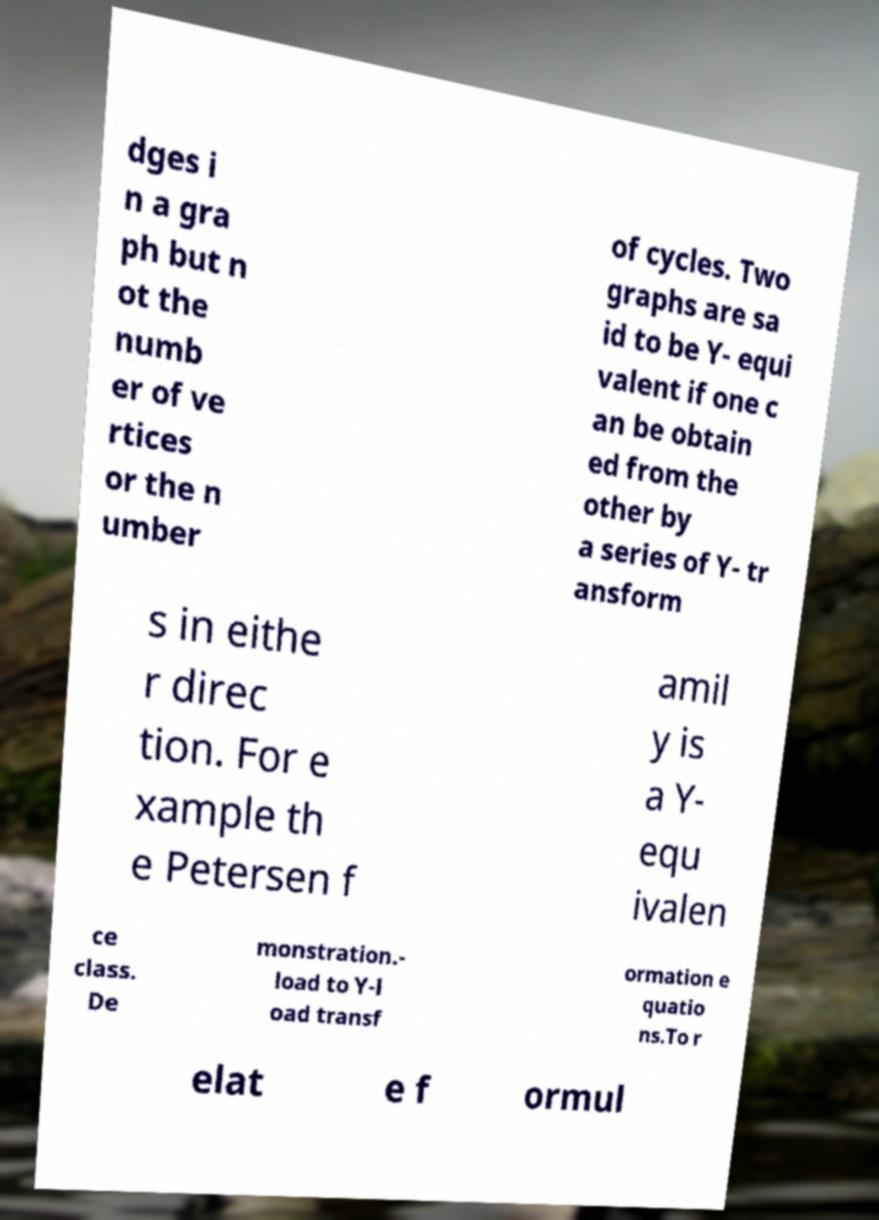Can you accurately transcribe the text from the provided image for me? dges i n a gra ph but n ot the numb er of ve rtices or the n umber of cycles. Two graphs are sa id to be Y- equi valent if one c an be obtain ed from the other by a series of Y- tr ansform s in eithe r direc tion. For e xample th e Petersen f amil y is a Y- equ ivalen ce class. De monstration.- load to Y-l oad transf ormation e quatio ns.To r elat e f ormul 